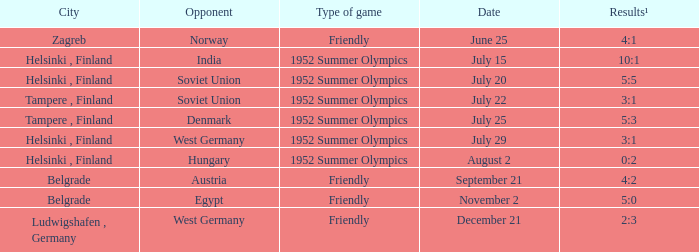What Type of game was played on Date of July 29? 1952 Summer Olympics. 